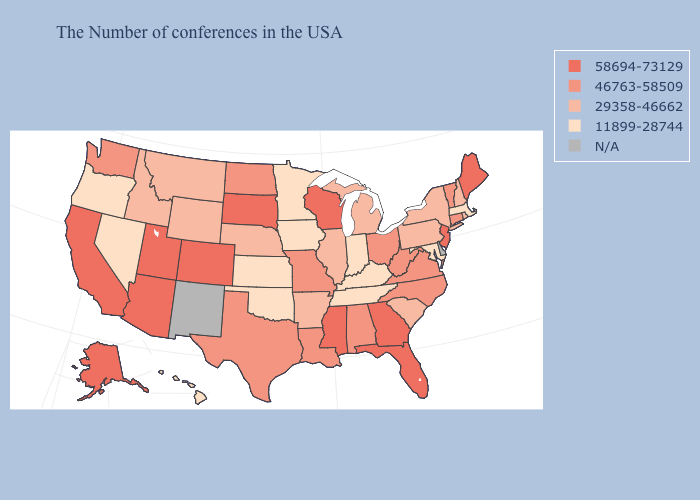Among the states that border Indiana , does Kentucky have the highest value?
Give a very brief answer. No. Does Alaska have the lowest value in the West?
Be succinct. No. What is the value of Florida?
Give a very brief answer. 58694-73129. What is the value of Oklahoma?
Write a very short answer. 11899-28744. Which states hav the highest value in the South?
Keep it brief. Florida, Georgia, Mississippi. What is the highest value in the USA?
Be succinct. 58694-73129. Which states have the lowest value in the MidWest?
Keep it brief. Indiana, Minnesota, Iowa, Kansas. Name the states that have a value in the range N/A?
Be succinct. Delaware, New Mexico. What is the highest value in the USA?
Keep it brief. 58694-73129. What is the highest value in states that border Wisconsin?
Keep it brief. 29358-46662. Name the states that have a value in the range 11899-28744?
Answer briefly. Massachusetts, Maryland, Kentucky, Indiana, Tennessee, Minnesota, Iowa, Kansas, Oklahoma, Nevada, Oregon, Hawaii. What is the highest value in states that border Minnesota?
Short answer required. 58694-73129. What is the value of Arkansas?
Write a very short answer. 29358-46662. Name the states that have a value in the range 46763-58509?
Keep it brief. Vermont, Connecticut, Virginia, North Carolina, West Virginia, Ohio, Alabama, Louisiana, Missouri, Texas, North Dakota, Washington. 